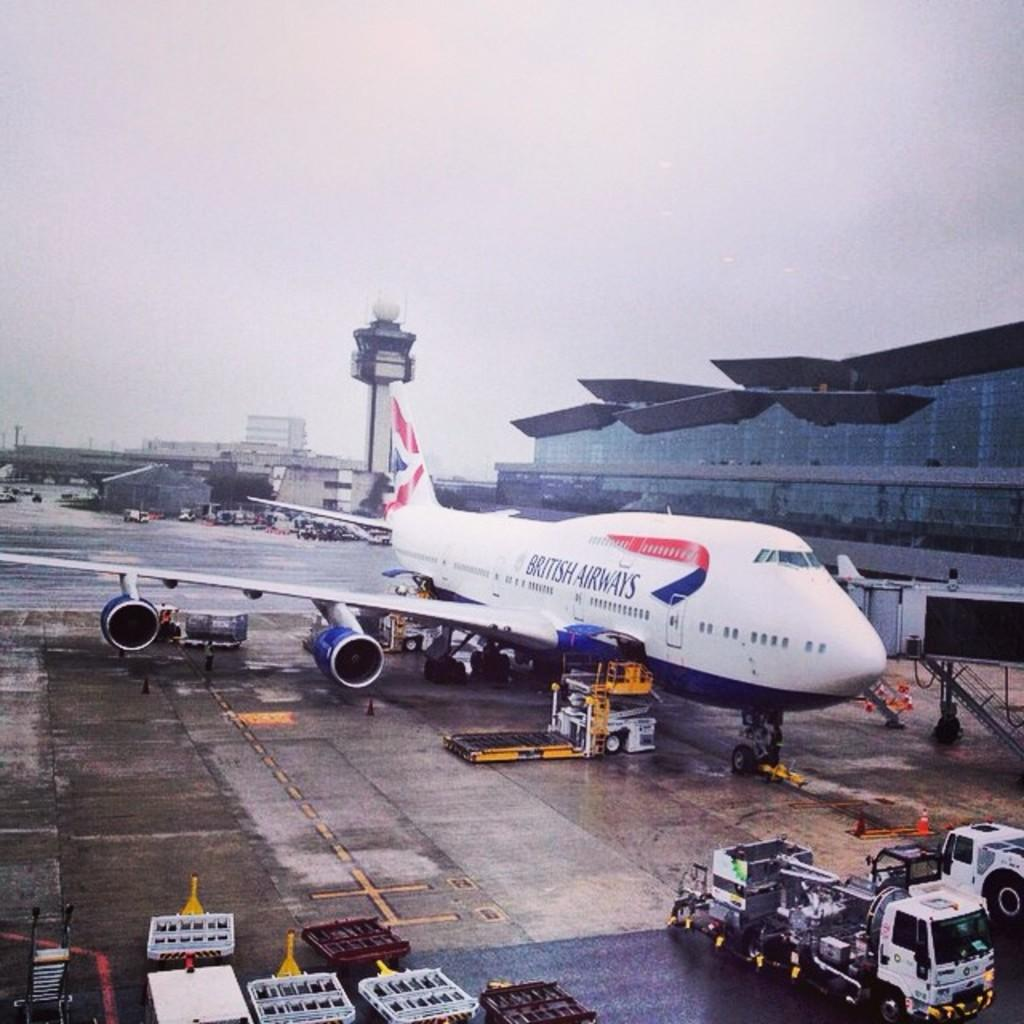What is the main subject of the image? The main subject of the image is an airplane. What other objects or structures can be seen in the image? There are vehicles and a building visible in the image. What can be seen in the sky in the image? The sky is visible in the image. What type of scissors can be seen cutting the airplane's wings in the image? There are no scissors or any cutting activity involving the airplane's wings in the image. 